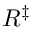Convert formula to latex. <formula><loc_0><loc_0><loc_500><loc_500>R ^ { \ddagger }</formula> 